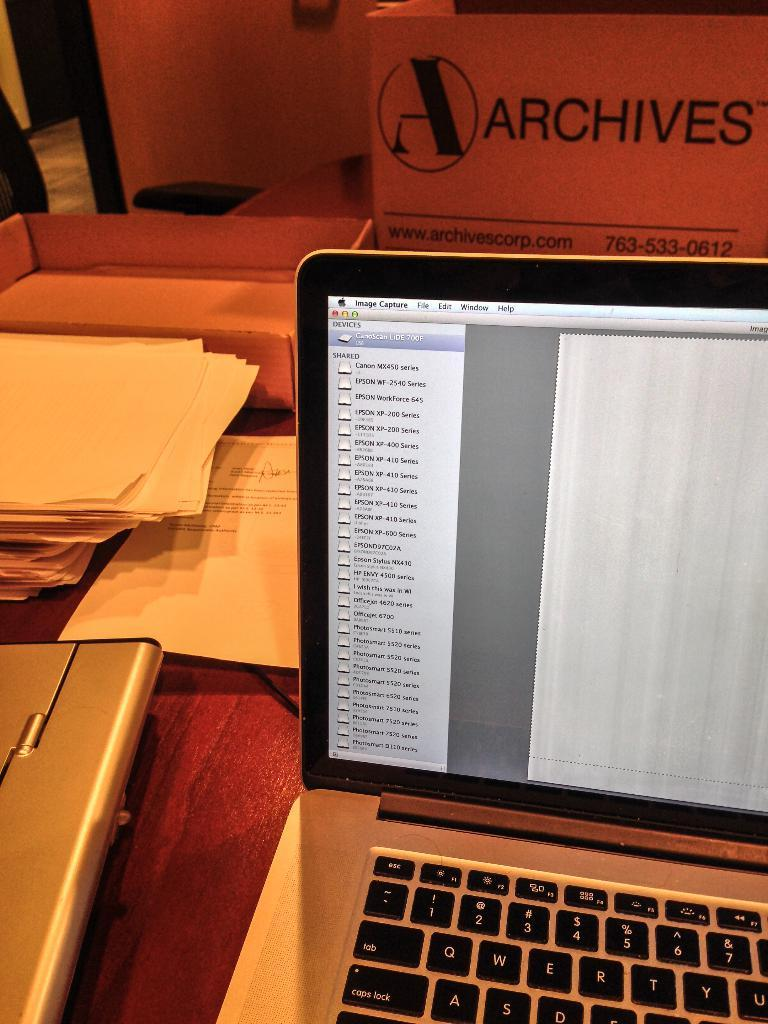<image>
Describe the image concisely. archives laptop over to the image capture screen 